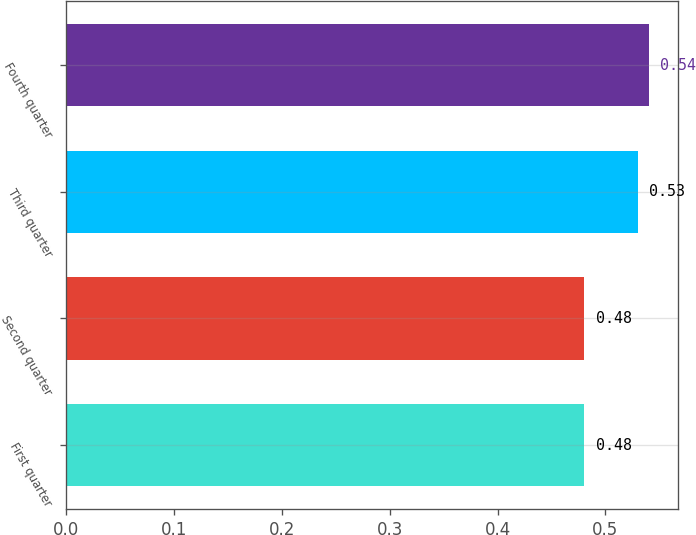Convert chart to OTSL. <chart><loc_0><loc_0><loc_500><loc_500><bar_chart><fcel>First quarter<fcel>Second quarter<fcel>Third quarter<fcel>Fourth quarter<nl><fcel>0.48<fcel>0.48<fcel>0.53<fcel>0.54<nl></chart> 